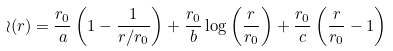Convert formula to latex. <formula><loc_0><loc_0><loc_500><loc_500>\wr ( r ) = \frac { r _ { 0 } } { a } \left ( 1 - \frac { 1 } { r / r _ { 0 } } \right ) + \frac { r _ { 0 } } { b } \log \left ( \frac { r } { r _ { 0 } } \right ) + \frac { r _ { 0 } } { c } \left ( \frac { r } { r _ { 0 } } - 1 \right )</formula> 